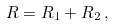<formula> <loc_0><loc_0><loc_500><loc_500>R = R _ { 1 } + R _ { 2 } \, ,</formula> 